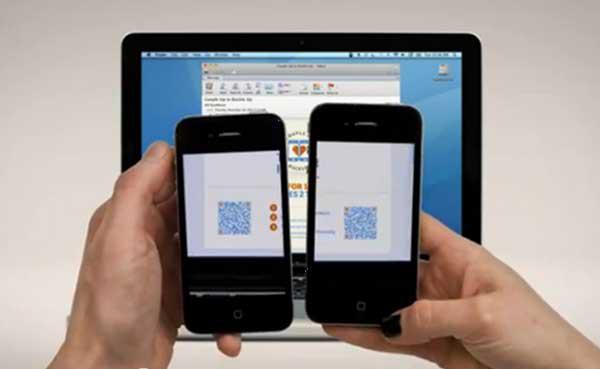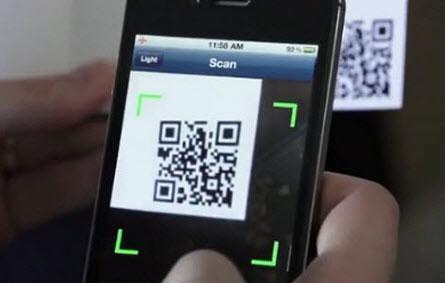The first image is the image on the left, the second image is the image on the right. Examine the images to the left and right. Is the description "There are three smartphones." accurate? Answer yes or no. Yes. The first image is the image on the left, the second image is the image on the right. Evaluate the accuracy of this statement regarding the images: "All of the phones have a QR Code on the screen.". Is it true? Answer yes or no. Yes. 